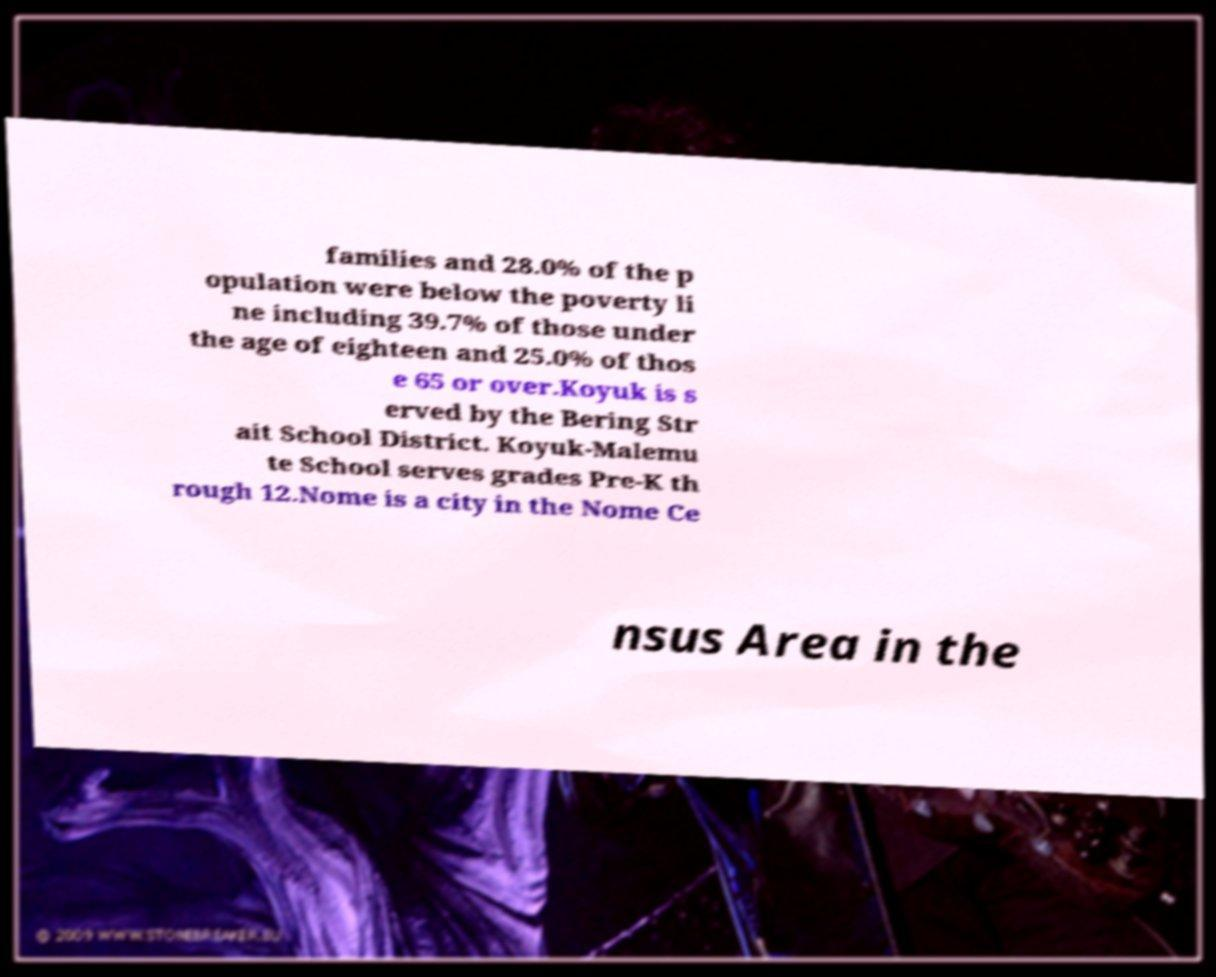What messages or text are displayed in this image? I need them in a readable, typed format. families and 28.0% of the p opulation were below the poverty li ne including 39.7% of those under the age of eighteen and 25.0% of thos e 65 or over.Koyuk is s erved by the Bering Str ait School District. Koyuk-Malemu te School serves grades Pre-K th rough 12.Nome is a city in the Nome Ce nsus Area in the 